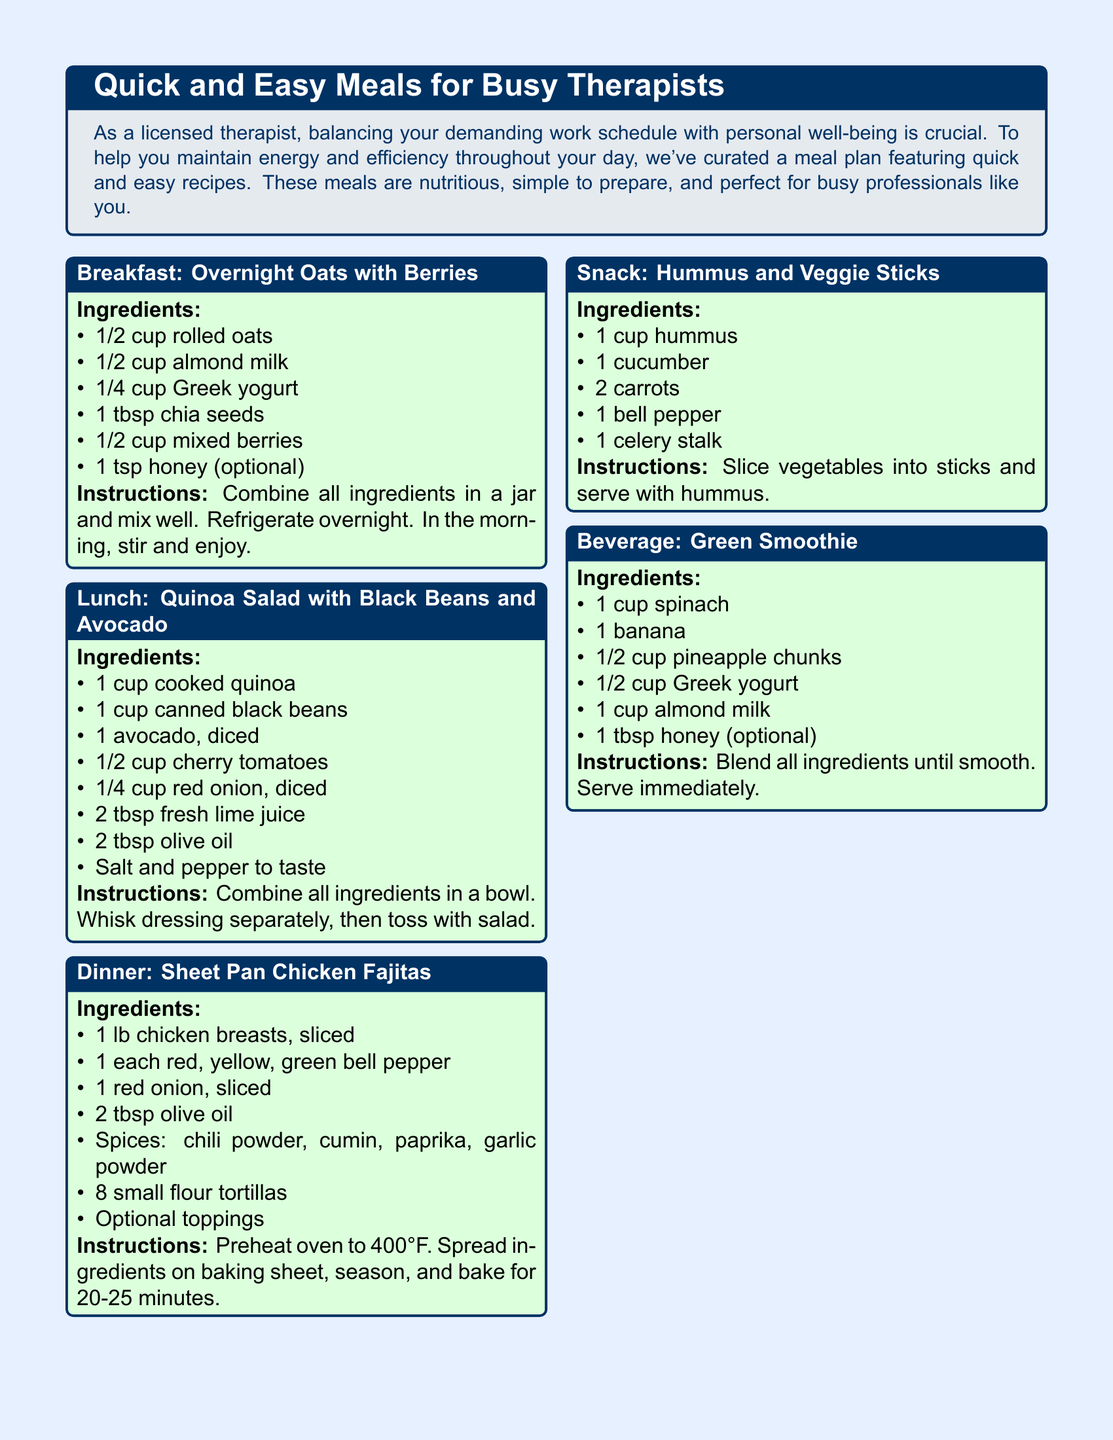What is the main purpose of the meal plan? The meal plan is designed to help busy therapists maintain energy and efficiency throughout their day.
Answer: Maintain energy and efficiency How many ingredients are needed for the breakfast recipe? The breakfast recipe for overnight oats lists six ingredients.
Answer: 6 What type of beans are used in the lunch recipe? The lunch recipe specifies the use of canned black beans.
Answer: Black beans How long should the sheet pan chicken fajitas be baked? The document indicates that the chicken fajitas should be baked for 20-25 minutes.
Answer: 20-25 minutes What additional option is mentioned for the hummus snack? The snack box does not specify additional options beyond the veggie sticks.
Answer: Veggie sticks What is the required oven temperature for the dinner recipe? The oven temperature for the sheet pan chicken fajitas is specified as 400°F.
Answer: 400°F Which ingredient is optional in the green smoothie? In the beverage recipe, honey is listed as an optional ingredient.
Answer: Honey What color represents the background of the meal plan document? The document has a light blue background color.
Answer: Light blue 